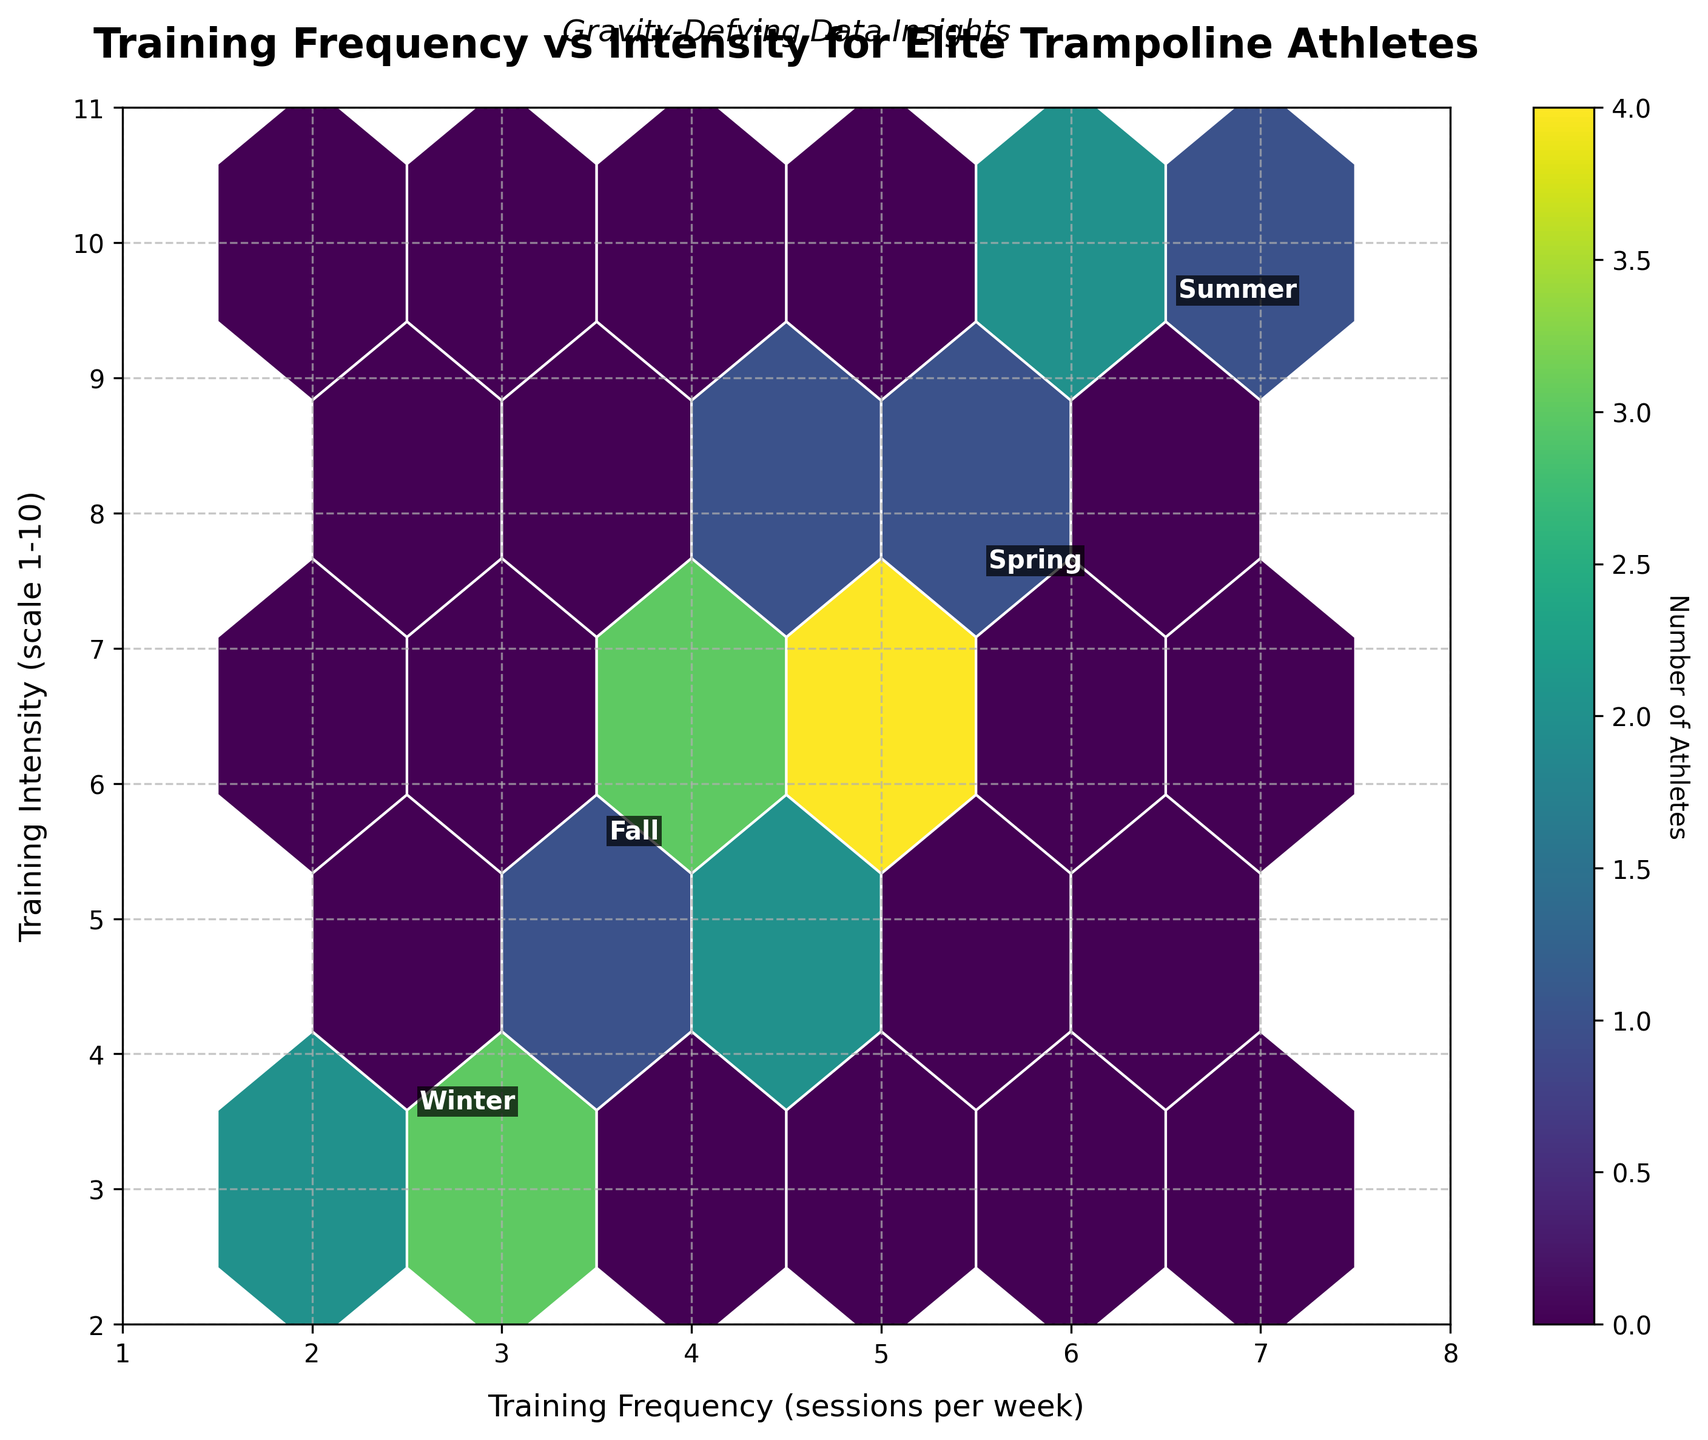what is the title of the hexbin plot? The title is written at the top of the plot and summarizes the main topic of the data visualization.
Answer: Training Frequency vs Intensity for Elite Trampoline Athletes What does the color bar represent in the hexbin plot? The color bar, usually located at the side of the plot, shows the scale of colors corresponding to the number of athletes.
Answer: Number of Athletes What is the x-axis labeled as? The label of the x-axis, usually found below the horizontal axis, indicates the measurement it represents.
Answer: Training Frequency (sessions per week) In which season is the training frequency and intensity combination of (6, 9) most common? By looking at the annotated positions on the plot, we can see where the text labels are placed relative to the hexagons. The position (6, 9) is closest to the annotation for "Summer."
Answer: Summer Where is the highest density of training sessions located? The hexagon with the darkest shade in the hexbin plot indicates the highest density of data points. By referencing the color bar, we can observe the frequency of the data point.
Answer: Approximately between (4-5, 6-7) How does the training frequency in winter compare to the other seasons? Looking at the plot, the winter session annotations are positioned near the lower end of the training frequency and intensity scales, indicating fewer sessions per week and a lower intensity rating compared to other seasons.
Answer: Lower Which season has the most variety in training intensity? Observing the annotated positions and the range of hexagons, Summer spans a broader range on the training intensity scale (7 to 10), indicating more variety.
Answer: Summer Comparing Spring and Winter, which one has a higher average training intensity? By looking at the positions of the annotated text and the density of the hexagons, we see that Spring's annotations (4-8) are higher on the intensity scale than Winter's (2-5).
Answer: Spring Identify the training frequency for Fall that has the highest density of athletes. The darkest hexagon in the Fall section would indicate the highest density in terms of frequency and intensity. The densest point for Fall appears near the (4, 6) position.
Answer: 4 sessions per week What is the range of training frequencies for Spring? By observing the Spring annotations, the data points for Spring training frequency are between 4 and 6 sessions per week.
Answer: 4 to 6 sessions per week 